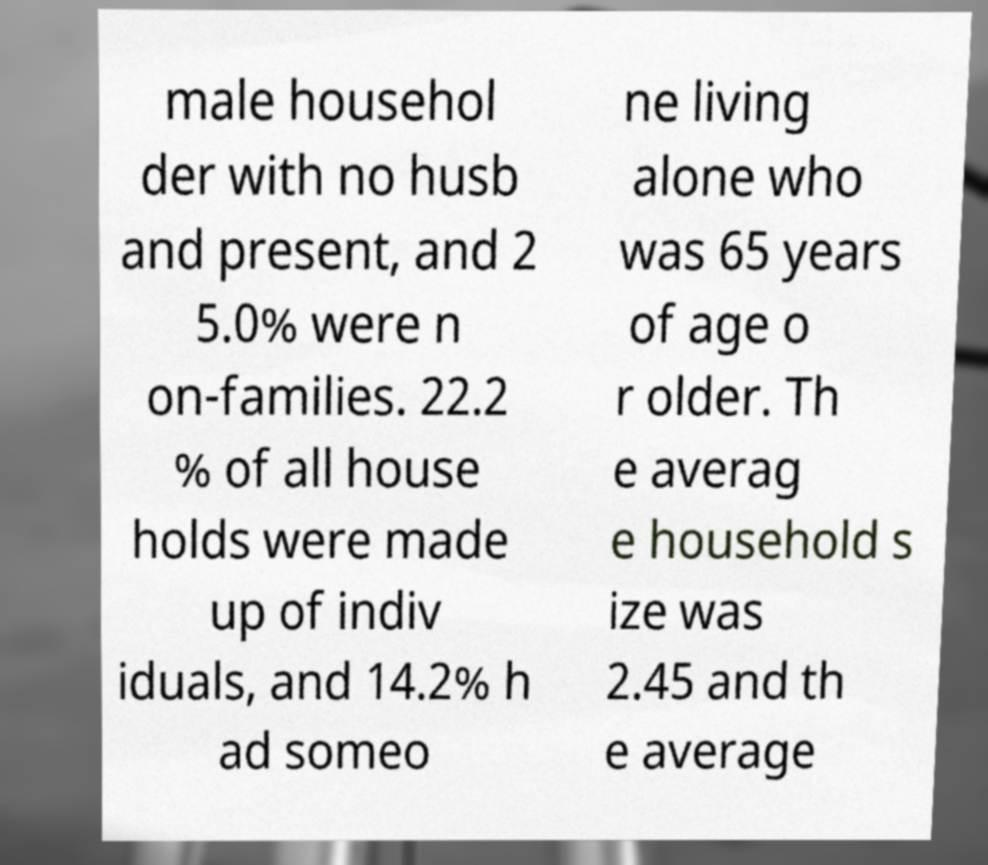Please identify and transcribe the text found in this image. male househol der with no husb and present, and 2 5.0% were n on-families. 22.2 % of all house holds were made up of indiv iduals, and 14.2% h ad someo ne living alone who was 65 years of age o r older. Th e averag e household s ize was 2.45 and th e average 